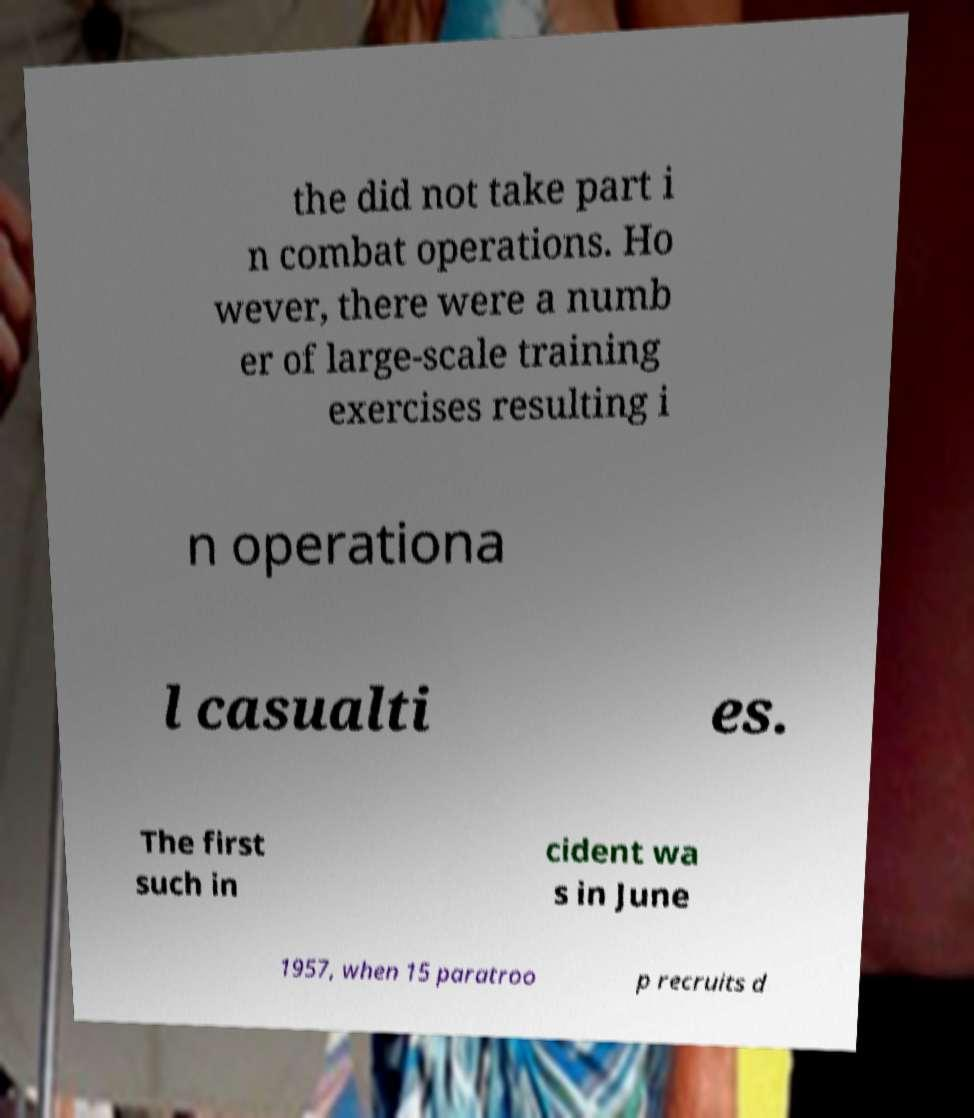What messages or text are displayed in this image? I need them in a readable, typed format. the did not take part i n combat operations. Ho wever, there were a numb er of large-scale training exercises resulting i n operationa l casualti es. The first such in cident wa s in June 1957, when 15 paratroo p recruits d 